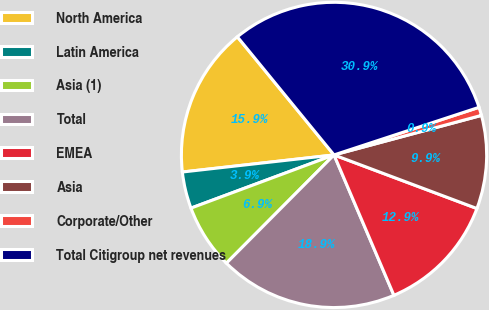<chart> <loc_0><loc_0><loc_500><loc_500><pie_chart><fcel>North America<fcel>Latin America<fcel>Asia (1)<fcel>Total<fcel>EMEA<fcel>Asia<fcel>Corporate/Other<fcel>Total Citigroup net revenues<nl><fcel>15.87%<fcel>3.88%<fcel>6.88%<fcel>18.87%<fcel>12.87%<fcel>9.88%<fcel>0.88%<fcel>30.86%<nl></chart> 